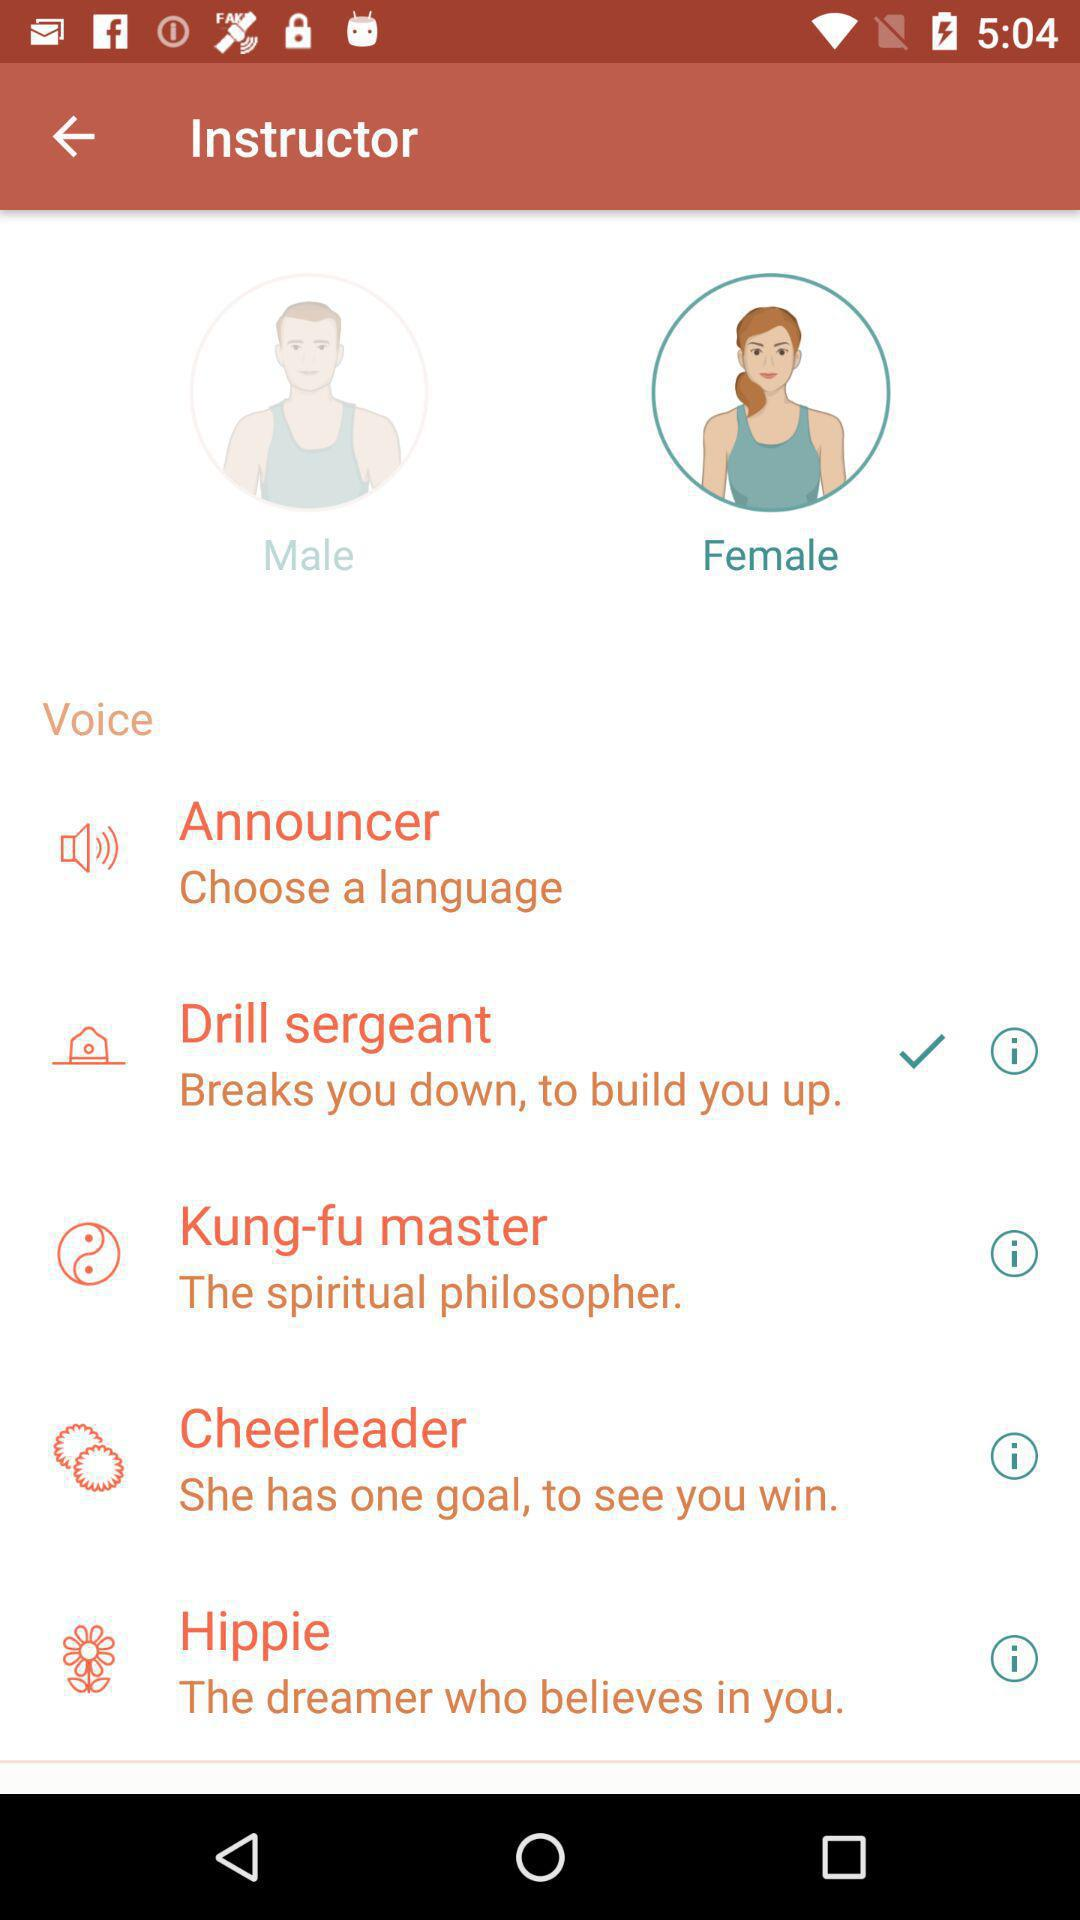What is the quality of Kung-Fu-master?
When the provided information is insufficient, respond with <no answer>. <no answer> 